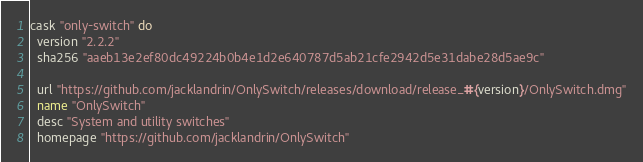Convert code to text. <code><loc_0><loc_0><loc_500><loc_500><_Ruby_>cask "only-switch" do
  version "2.2.2"
  sha256 "aaeb13e2ef80dc49224b0b4e1d2e640787d5ab21cfe2942d5e31dabe28d5ae9c"

  url "https://github.com/jacklandrin/OnlySwitch/releases/download/release_#{version}/OnlySwitch.dmg"
  name "OnlySwitch"
  desc "System and utility switches"
  homepage "https://github.com/jacklandrin/OnlySwitch"
</code> 